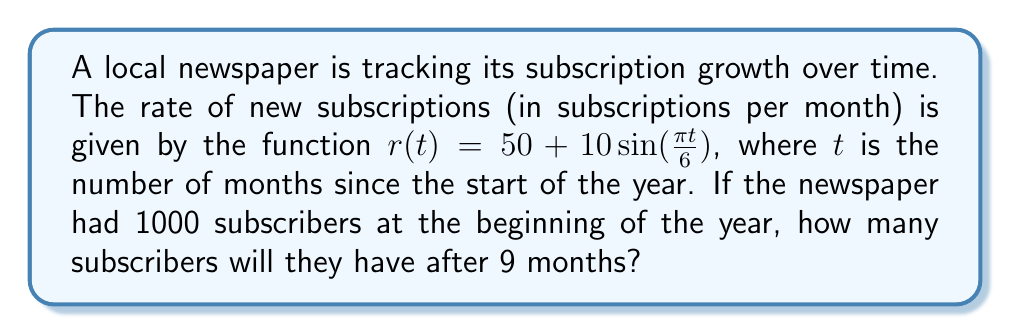Teach me how to tackle this problem. To solve this problem, we need to use integration to find the total number of new subscribers over the 9-month period and add that to the initial number of subscribers.

1. Set up the integral:
   The total number of new subscribers is the integral of the rate function from 0 to 9 months.
   $$\int_0^9 r(t) dt = \int_0^9 (50 + 10\sin(\frac{\pi t}{6})) dt$$

2. Integrate the function:
   $$\int_0^9 50 dt + \int_0^9 10\sin(\frac{\pi t}{6}) dt$$
   
   For the first part: $\int_0^9 50 dt = 50t|_0^9 = 450$
   
   For the second part: $\int_0^9 10\sin(\frac{\pi t}{6}) dt = -\frac{60}{\pi} \cos(\frac{\pi t}{6})|_0^9$
   
   $= -\frac{60}{\pi} [\cos(\frac{3\pi}{2}) - \cos(0)]$
   $= -\frac{60}{\pi} [0 - 1] = \frac{60}{\pi}$

3. Sum the results:
   Total new subscribers = $450 + \frac{60}{\pi} \approx 469.1$

4. Add to initial subscribers:
   Total subscribers after 9 months = $1000 + 469.1 = 1469.1$
Answer: After 9 months, the newspaper will have approximately 1469 subscribers (rounded to the nearest whole number). 